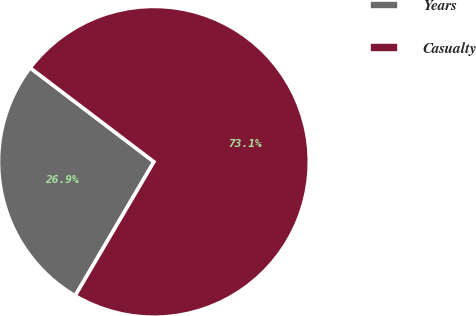<chart> <loc_0><loc_0><loc_500><loc_500><pie_chart><fcel>Years<fcel>Casualty<nl><fcel>26.88%<fcel>73.12%<nl></chart> 